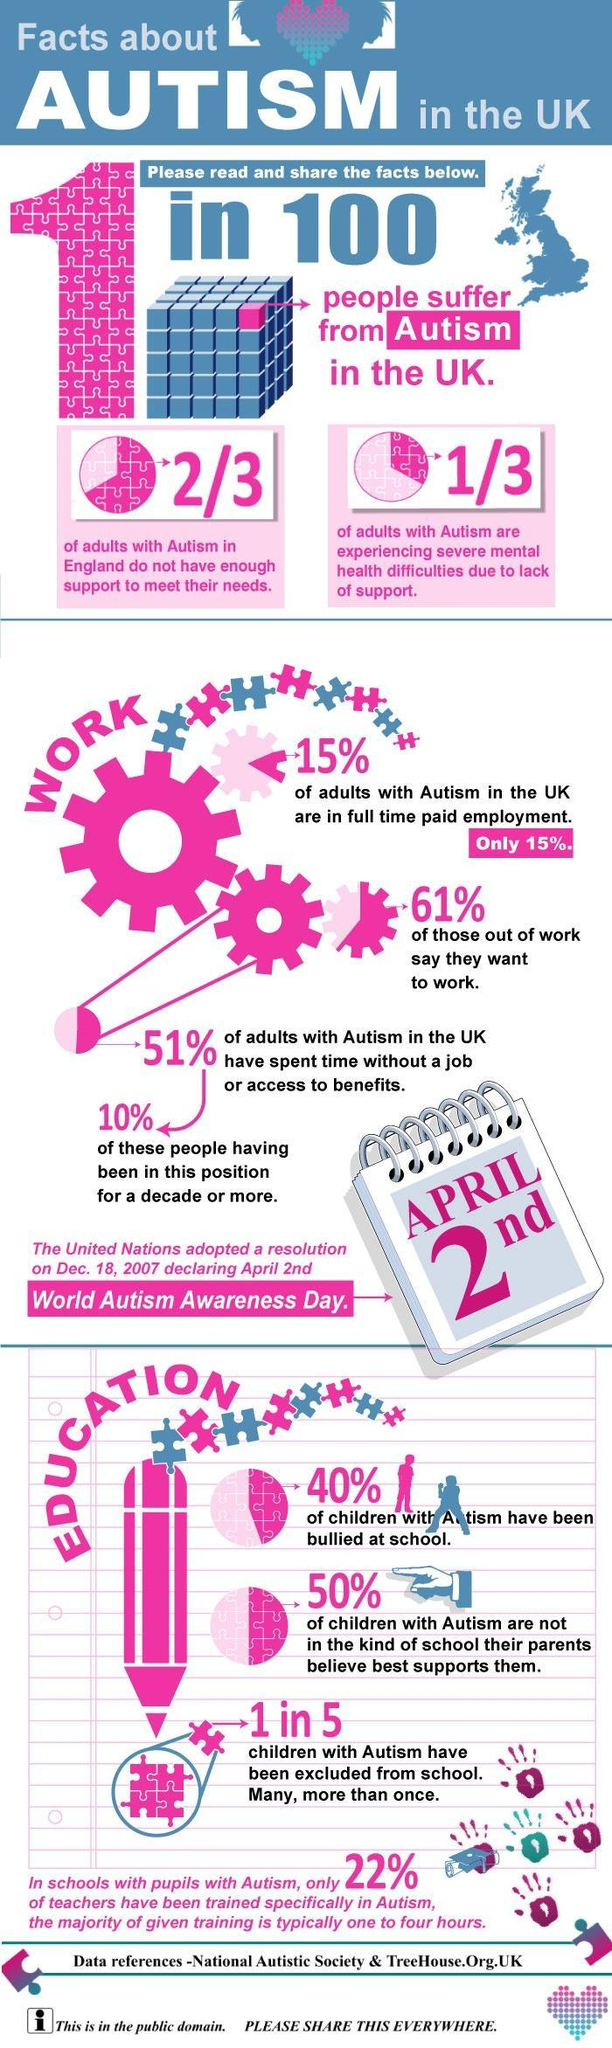What percent of autistic children have been excluded from school ?
Answer the question with a short phrase. 20% How many pink cubes are there on the Rubik's cube ? 1 What percentage of teachers have not been trained to deal with autism ? 78% What percent of parents are unhappy with their autistic child's school ? 50% What is the colour of the pencil - green, blue, pink or purple ? Pink What percent of autistic students have been bullied in school ? 40% What is the name of the mental disorder affecting 1 out of every hundred in UK ? Autism When is World Awareness Autism day ? April 2nd What percent of autistic adults in UK have a full time job ? 15% 